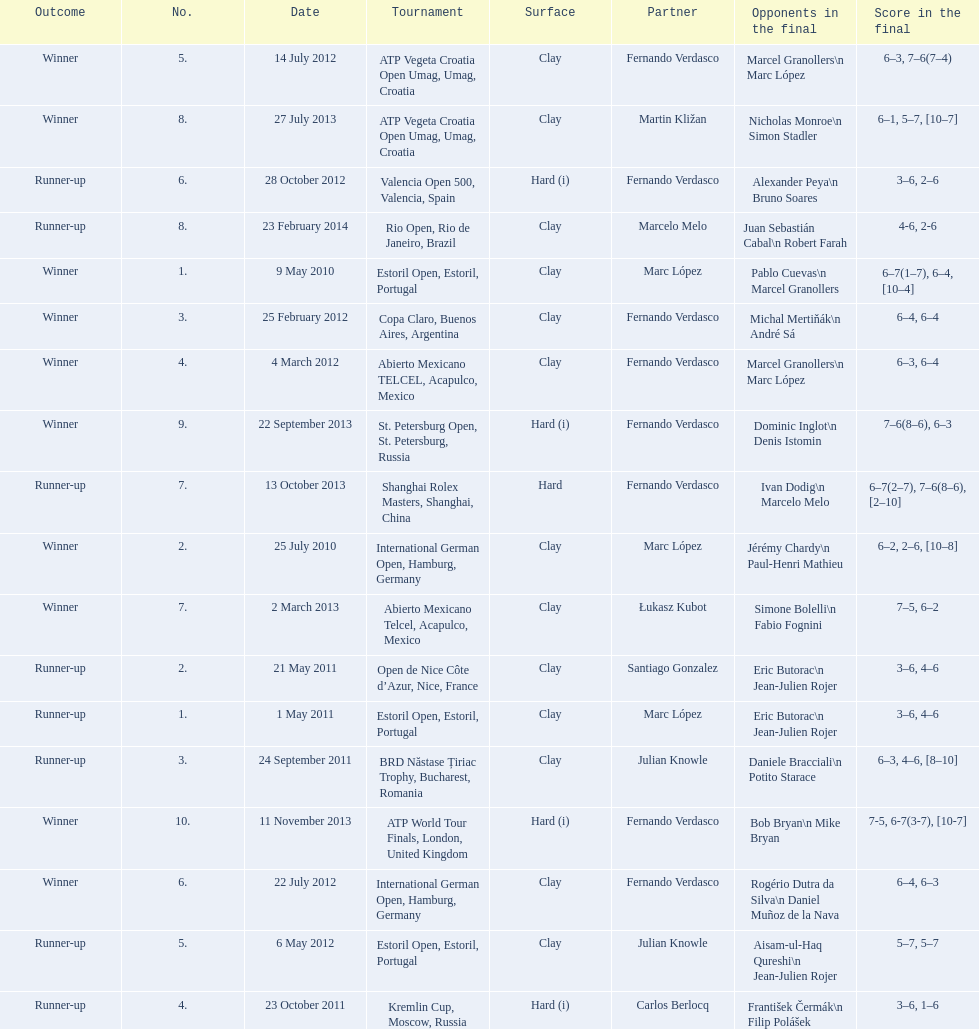How many tournaments has this player won in his career so far? 10. 